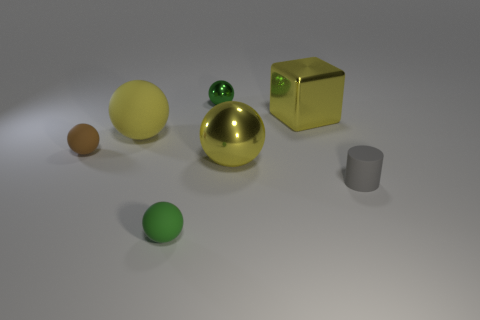Subtract all small green spheres. How many spheres are left? 3 Add 1 metallic cubes. How many objects exist? 8 Subtract all green balls. How many balls are left? 3 Subtract 1 cylinders. How many cylinders are left? 0 Subtract all purple cubes. How many yellow spheres are left? 2 Subtract all big yellow metallic spheres. Subtract all matte things. How many objects are left? 2 Add 2 large yellow metal things. How many large yellow metal things are left? 4 Add 4 yellow rubber spheres. How many yellow rubber spheres exist? 5 Subtract 0 cyan cubes. How many objects are left? 7 Subtract all cylinders. How many objects are left? 6 